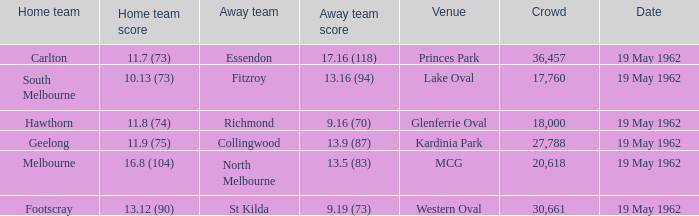What day is the venue the western oval? 19 May 1962. 